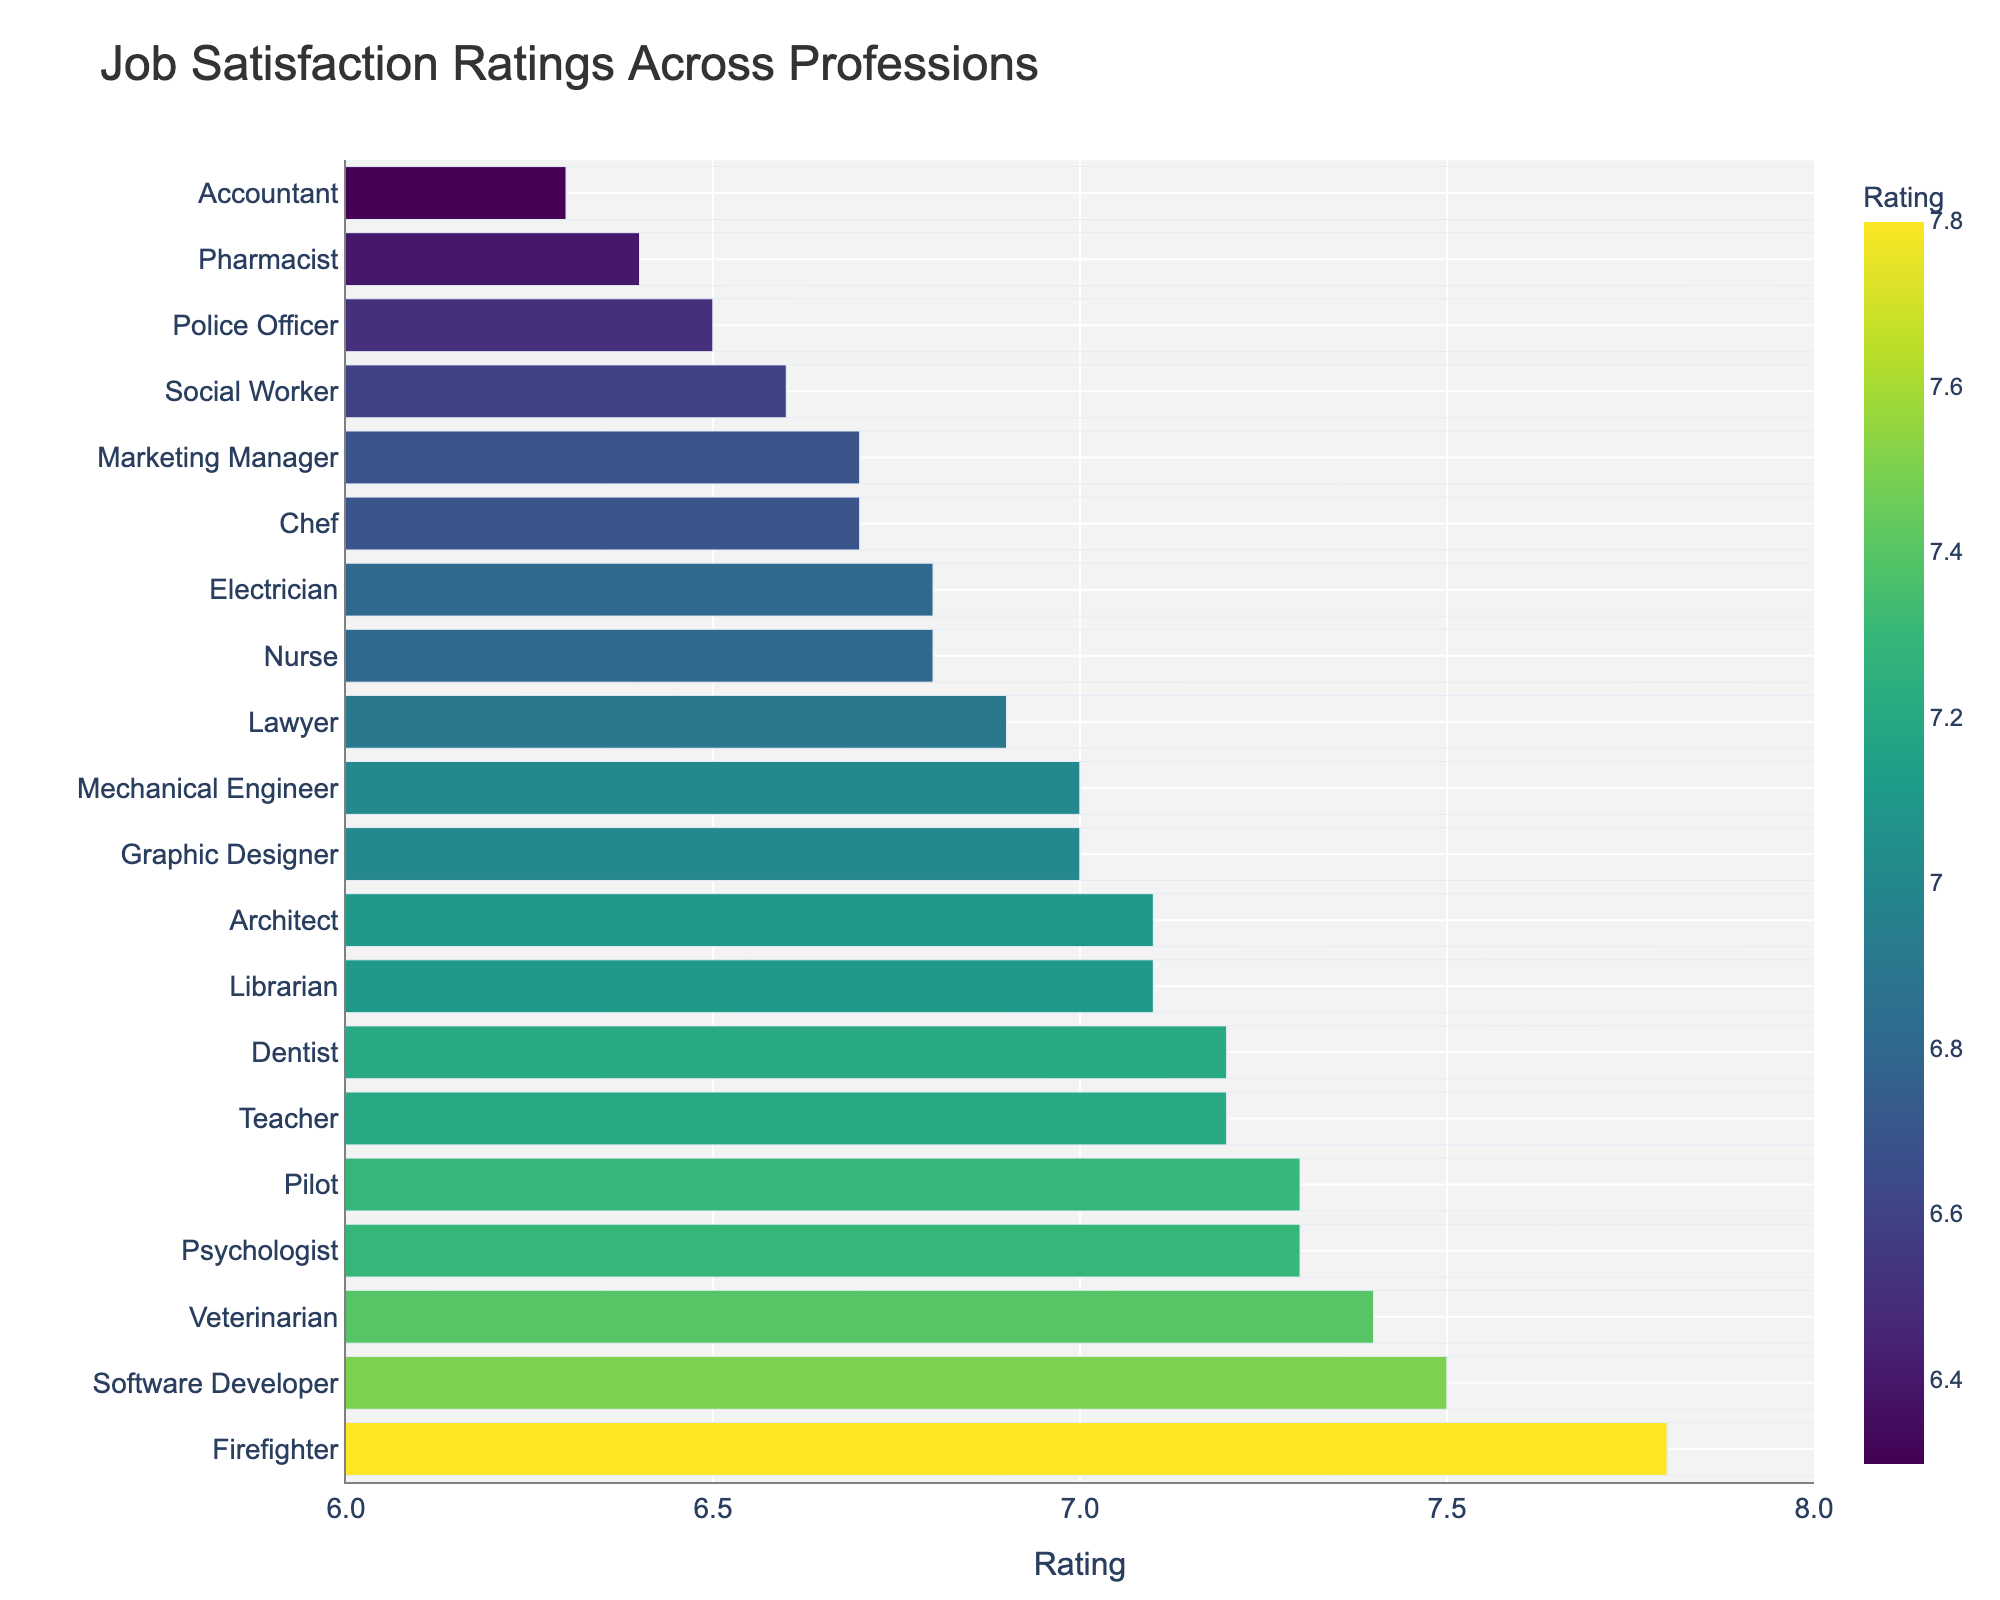Which profession has the highest job satisfaction rating, and what is the rating? The bar chart shows the job satisfaction ratings of various professions, and the bar with the highest value represents the top rating. From the chart, Firefighter has the highest rating.
Answer: Firefighter, 7.8 How does the job satisfaction rating of a Police Officer compare to a Librarian? Locate both the Police Officer and Librarian bars in the chart and compare their lengths or positions along the rating axis. Police Officer has a rating of 6.5, while Librarian has a rating of 7.1, making the Librarian's rating higher.
Answer: Librarian rating is higher by 0.6 What is the average job satisfaction rating across all professions? Add up all the job satisfaction ratings and divide by the number of professions to find the average. This requires summing all ratings (7.2+6.8+7.5+6.5+6.3+6.7+6.9+7.1+7.4+7.8+6.6+7.0+6.4+7.3+7.2+6.8+7.1+6.7+7.3+7.0 = 141.0), then dividing by 20 (number of professions).
Answer: (141.0 / 20) = 7.05 How many professions have a job satisfaction rating of 7.0 or higher? Count all the bars with ratings equal to or above the 7.0 mark. Professions: Teacher, Software Developer, Architect, Veterinarian, Firefighter, Graphic Designer, Pilot, Dentist, Librarian, Psychologist, and Mechanical Engineer.
Answer: 11 Which profession has the lowest job satisfaction rating and what is the rating? Identify the bar with the smallest value on the rating axis. The shortest bar represents the profession with the lowest satisfaction rating, which is Accountant.
Answer: Accountant, 6.3 What is the combined rating of the top three professions with the highest job satisfaction? Identify the top three bars with the highest ratings and sum their values. The top three are Firefighter (7.8), Software Developer (7.5), and Veterinarian (7.4).
Answer: 7.8 + 7.5 + 7.4 = 22.7 Compare the job satisfaction ratings of Nurses and Police Officers, which one is higher and by how much? Locate the bars for both Nurse and Police Officer, then compare their values. Nurse has a rating of 6.8 and Police Officer has 6.5. Calculate the difference between the two ratings.
Answer: Nurse by 0.3 What is the median job satisfaction rating among all professions? To find the median, sort the ratings in ascending order and identify the middle number. With 20 data points, the median is the average of the 10th and 11th values in the sorted list. Sorted Ratings: [6.3, 6.4, 6.5, 6.6, 6.7, 6.7, 6.8, 6.8, 6.9, 7.0, 7.0, 7.1, 7.1, 7.2, 7.2, 7.3, 7.3, 7.4, 7.5, 7.8], middle values are 7.0 and 7.0.
Answer: (7.0+7.0)/2 = 7.0 How does the job satisfaction rating of a Dentist compare to that of a Graphic Designer? Locate and compare the bars for Dentist and Graphic Designer. Both have comparable heights and rating values. Dentist has a rating of 7.2 and Graphic Designer has a 7.0 rating.
Answer: Dentist is higher by 0.2 